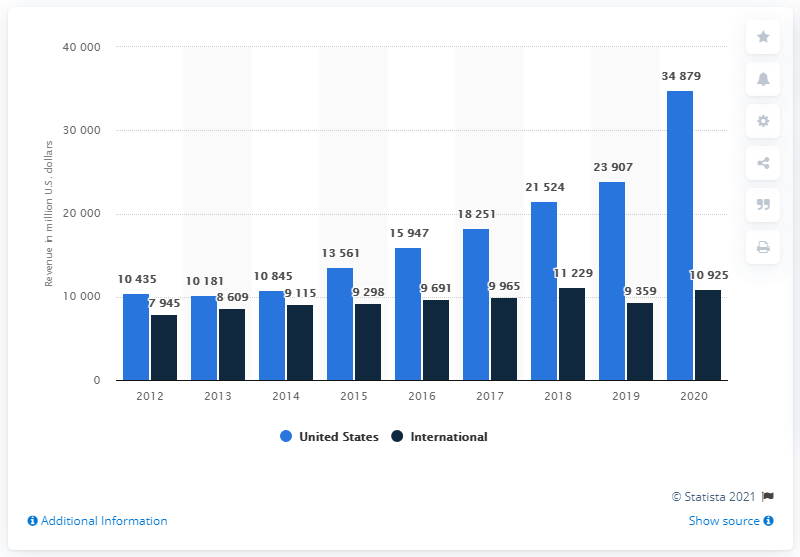Draw attention to some important aspects in this diagram. The highest revenue generated by AbbVie from the international market between 2012 and 2020 was 11,229. AbbVie generated approximately 34,879 revenue in the United States in 2020. The total revenue for AbbVie from both the international and US markets for the year 2020 was approximately 45,804. 